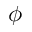<formula> <loc_0><loc_0><loc_500><loc_500>\phi</formula> 